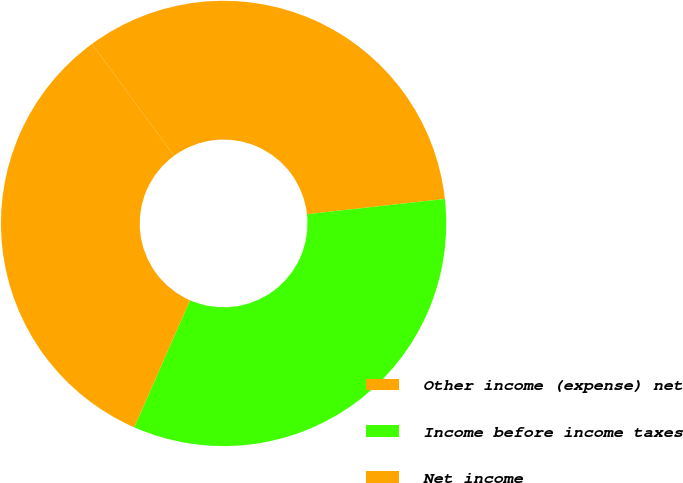Convert chart. <chart><loc_0><loc_0><loc_500><loc_500><pie_chart><fcel>Other income (expense) net<fcel>Income before income taxes<fcel>Net income<nl><fcel>33.31%<fcel>33.33%<fcel>33.36%<nl></chart> 